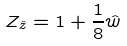Convert formula to latex. <formula><loc_0><loc_0><loc_500><loc_500>Z _ { \hat { z } } = 1 + \frac { 1 } { 8 } \hat { w }</formula> 